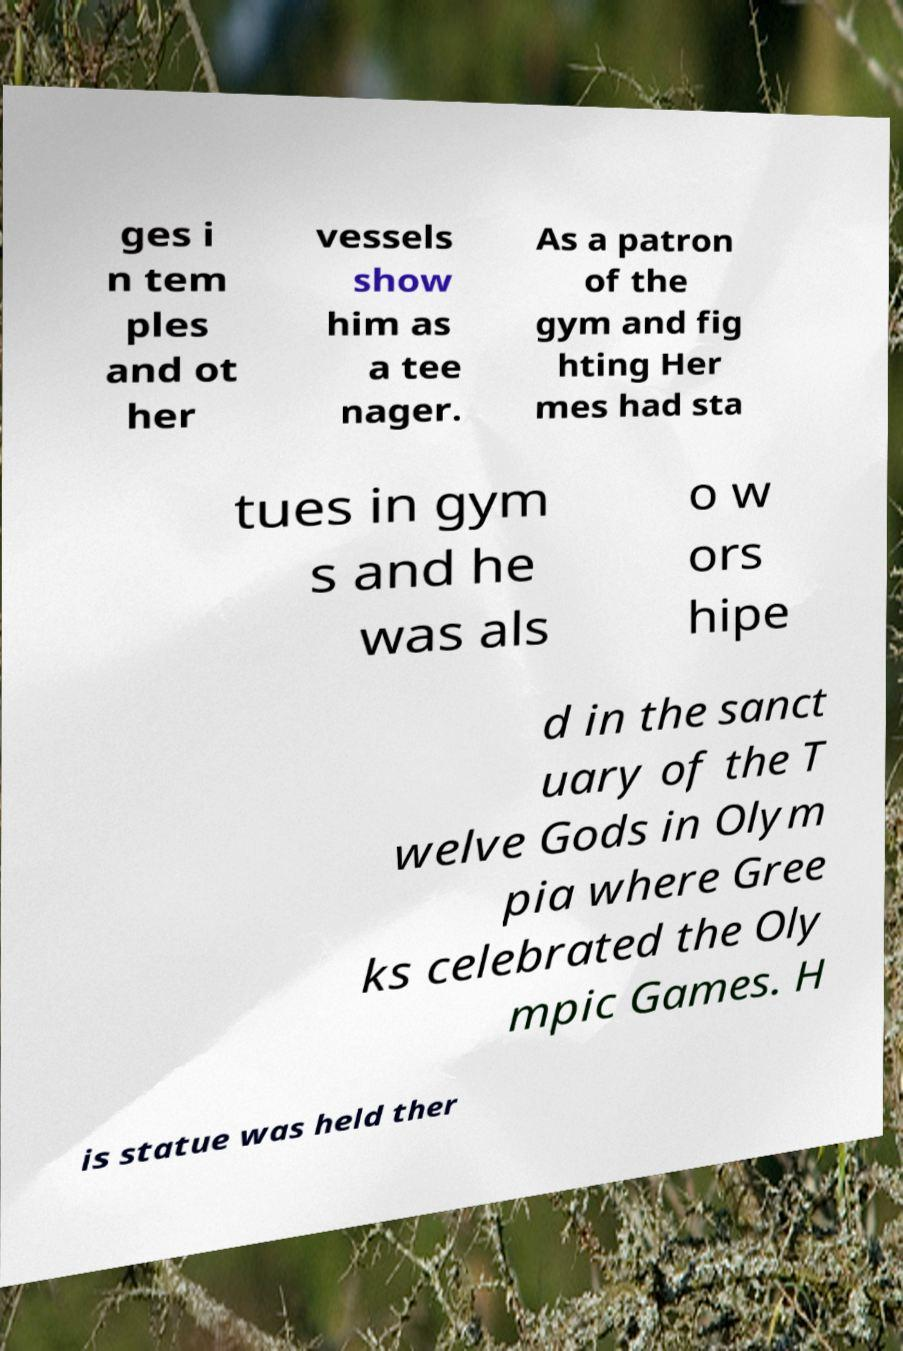There's text embedded in this image that I need extracted. Can you transcribe it verbatim? ges i n tem ples and ot her vessels show him as a tee nager. As a patron of the gym and fig hting Her mes had sta tues in gym s and he was als o w ors hipe d in the sanct uary of the T welve Gods in Olym pia where Gree ks celebrated the Oly mpic Games. H is statue was held ther 